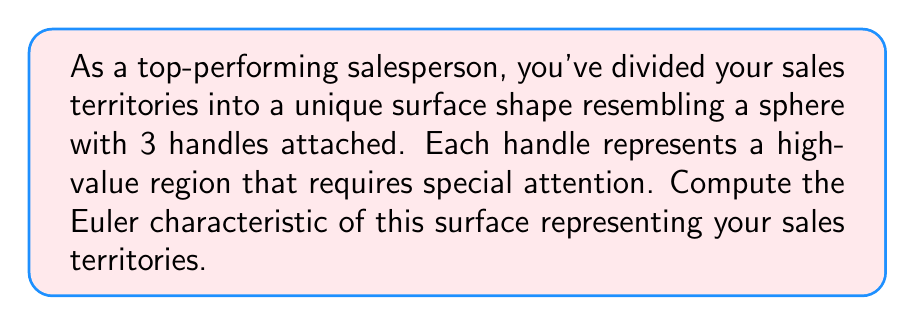Provide a solution to this math problem. To compute the Euler characteristic of this surface, we'll use the formula:

$$\chi = V - E + F$$

Where:
$\chi$ is the Euler characteristic
$V$ is the number of vertices
$E$ is the number of edges
$F$ is the number of faces

For a sphere with $g$ handles (also known as a genus-$g$ surface), the Euler characteristic is given by:

$$\chi = 2 - 2g$$

In this case, we have a sphere (genus 0) with 3 additional handles, so the total genus is 3.

Substituting $g = 3$ into the formula:

$$\chi = 2 - 2(3)$$
$$\chi = 2 - 6$$
$$\chi = -4$$

This result can be interpreted in terms of sales territories:
1. The main sphere represents your primary market.
2. Each handle represents a specialized, high-value territory.
3. The negative Euler characteristic indicates a complex, interconnected market structure with multiple pathways between territories, offering opportunities for strategic sales approaches.
Answer: $\chi = -4$ 